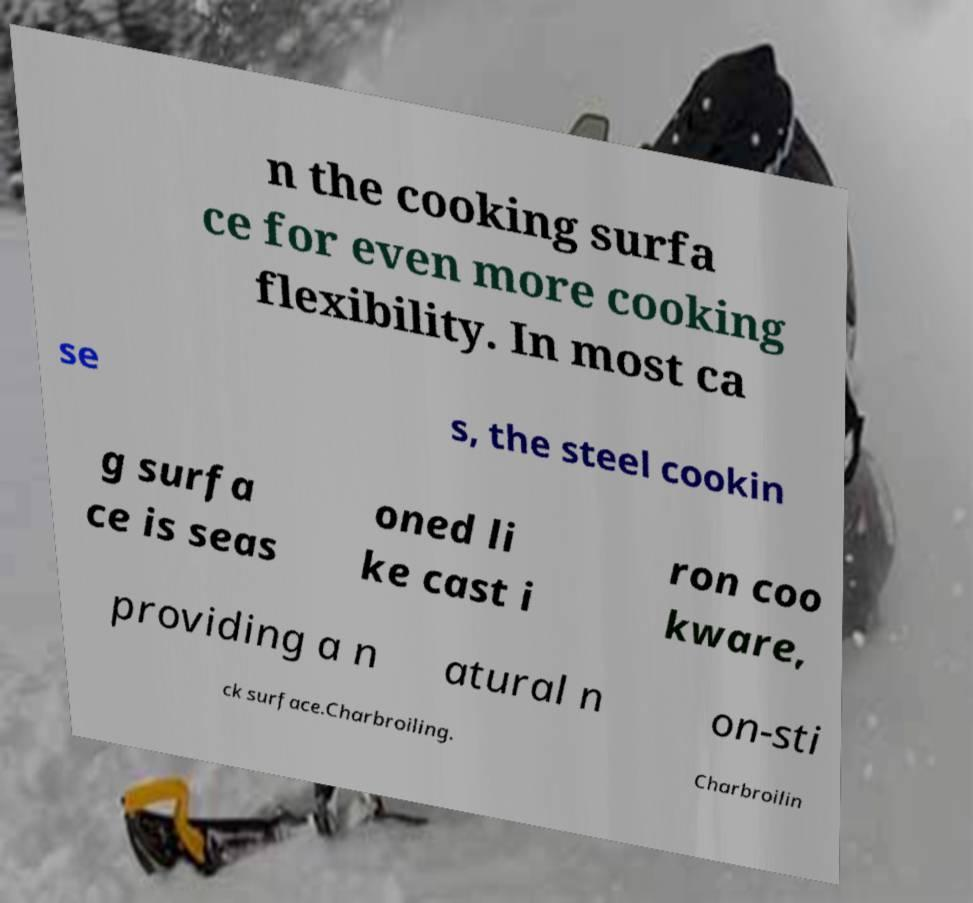Can you read and provide the text displayed in the image?This photo seems to have some interesting text. Can you extract and type it out for me? n the cooking surfa ce for even more cooking flexibility. In most ca se s, the steel cookin g surfa ce is seas oned li ke cast i ron coo kware, providing a n atural n on-sti ck surface.Charbroiling. Charbroilin 